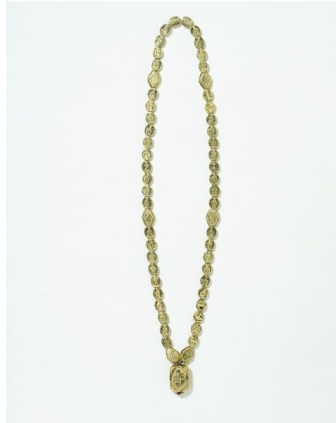Describe the cultural significance a necklace like this might hold. In many cultures, a necklace like this could hold significant meaning. The use of gold often symbolizes wealth, prosperity, and high status. The intricate floral design might suggest a connection to nature, fertility, and growth. Such a necklace could be handed down through generations, signifying the continuity of family traditions and heritage. It might be worn during important ceremonies, such as weddings or religious events, to convey respect and honor to the wearer's lineage. In some societies, such adornments are believed to carry protective properties, blessing the wearer with good fortune and warding off negativity. Imagine this necklace was found in an ancient tomb. What would archeologists infer about its owner? If this necklace were found in an ancient tomb, archaeologists might infer that its owner was a person of considerable importance and high social status. The quality and craftsmanship of the necklace, particularly its gold composition and intricate design, would suggest that the wearer was wealthy, possibly a member of the elite class. The floral etching on the pendant might indicate the owner’s connection to nature or a particular fondness for certain aesthetic symbols prevalent in their culture. This find could launch discussions about the funeral customs, aesthetic sensibilities, and social hierarchy of the time, providing valuable insights into the civilization's cultural and economic fabric. 